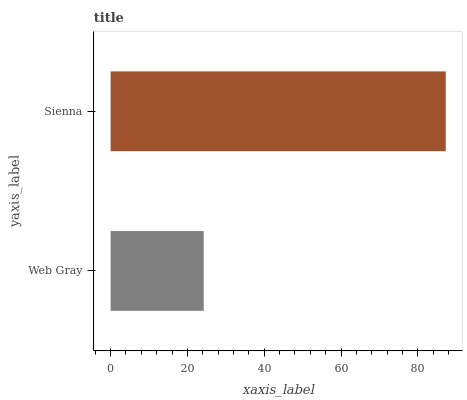Is Web Gray the minimum?
Answer yes or no. Yes. Is Sienna the maximum?
Answer yes or no. Yes. Is Sienna the minimum?
Answer yes or no. No. Is Sienna greater than Web Gray?
Answer yes or no. Yes. Is Web Gray less than Sienna?
Answer yes or no. Yes. Is Web Gray greater than Sienna?
Answer yes or no. No. Is Sienna less than Web Gray?
Answer yes or no. No. Is Sienna the high median?
Answer yes or no. Yes. Is Web Gray the low median?
Answer yes or no. Yes. Is Web Gray the high median?
Answer yes or no. No. Is Sienna the low median?
Answer yes or no. No. 